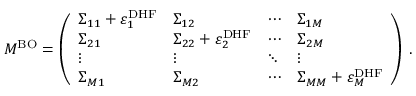<formula> <loc_0><loc_0><loc_500><loc_500>M ^ { B O } = \left ( \begin{array} { l l l l } { \Sigma _ { 1 1 } + \varepsilon _ { 1 } ^ { D H F } } & { \Sigma _ { 1 2 } } & { \cdots } & { \Sigma _ { 1 M } } \\ { \Sigma _ { 2 1 } } & { \Sigma _ { 2 2 } + \varepsilon _ { 2 } ^ { D H F } } & { \cdots } & { \Sigma _ { 2 M } } \\ { \vdots } & { \vdots } & { \ddots } & { \vdots } \\ { \Sigma _ { M 1 } } & { \Sigma _ { M 2 } } & { \cdots } & { \Sigma _ { M M } + \varepsilon _ { M } ^ { D H F } } \end{array} \right ) \, .</formula> 